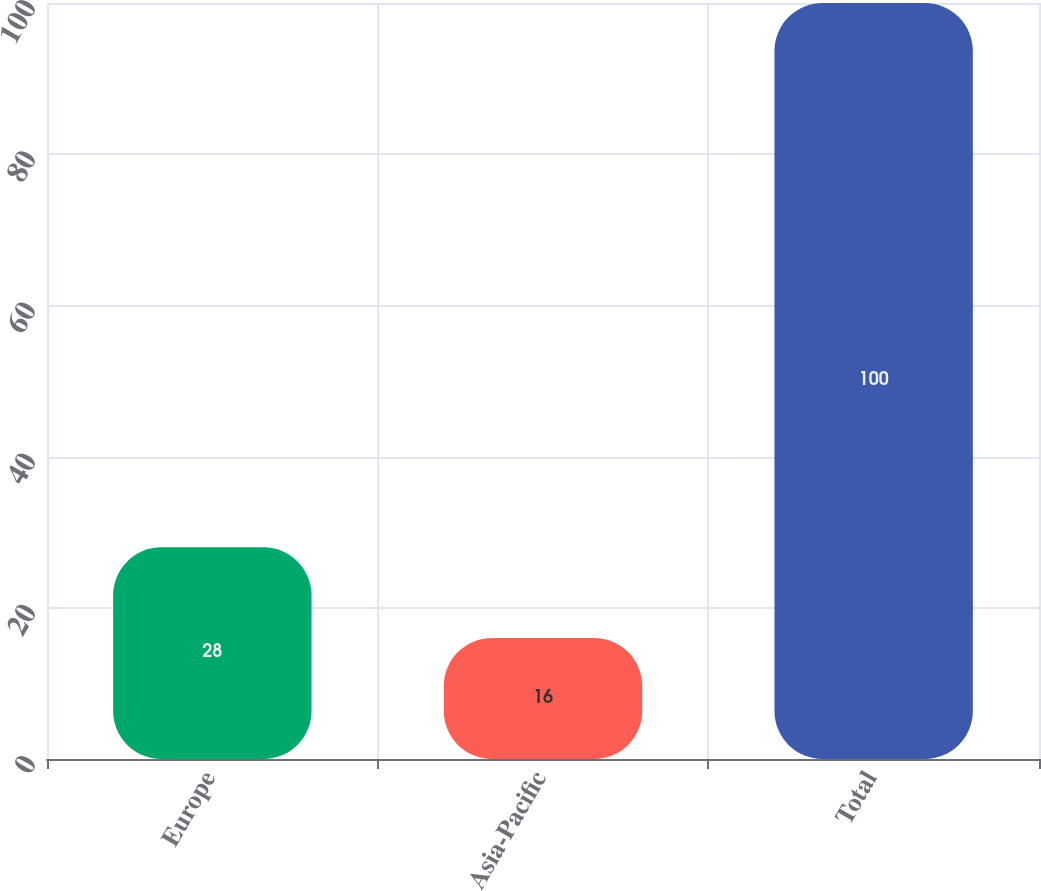Convert chart to OTSL. <chart><loc_0><loc_0><loc_500><loc_500><bar_chart><fcel>Europe<fcel>Asia-Pacific<fcel>Total<nl><fcel>28<fcel>16<fcel>100<nl></chart> 